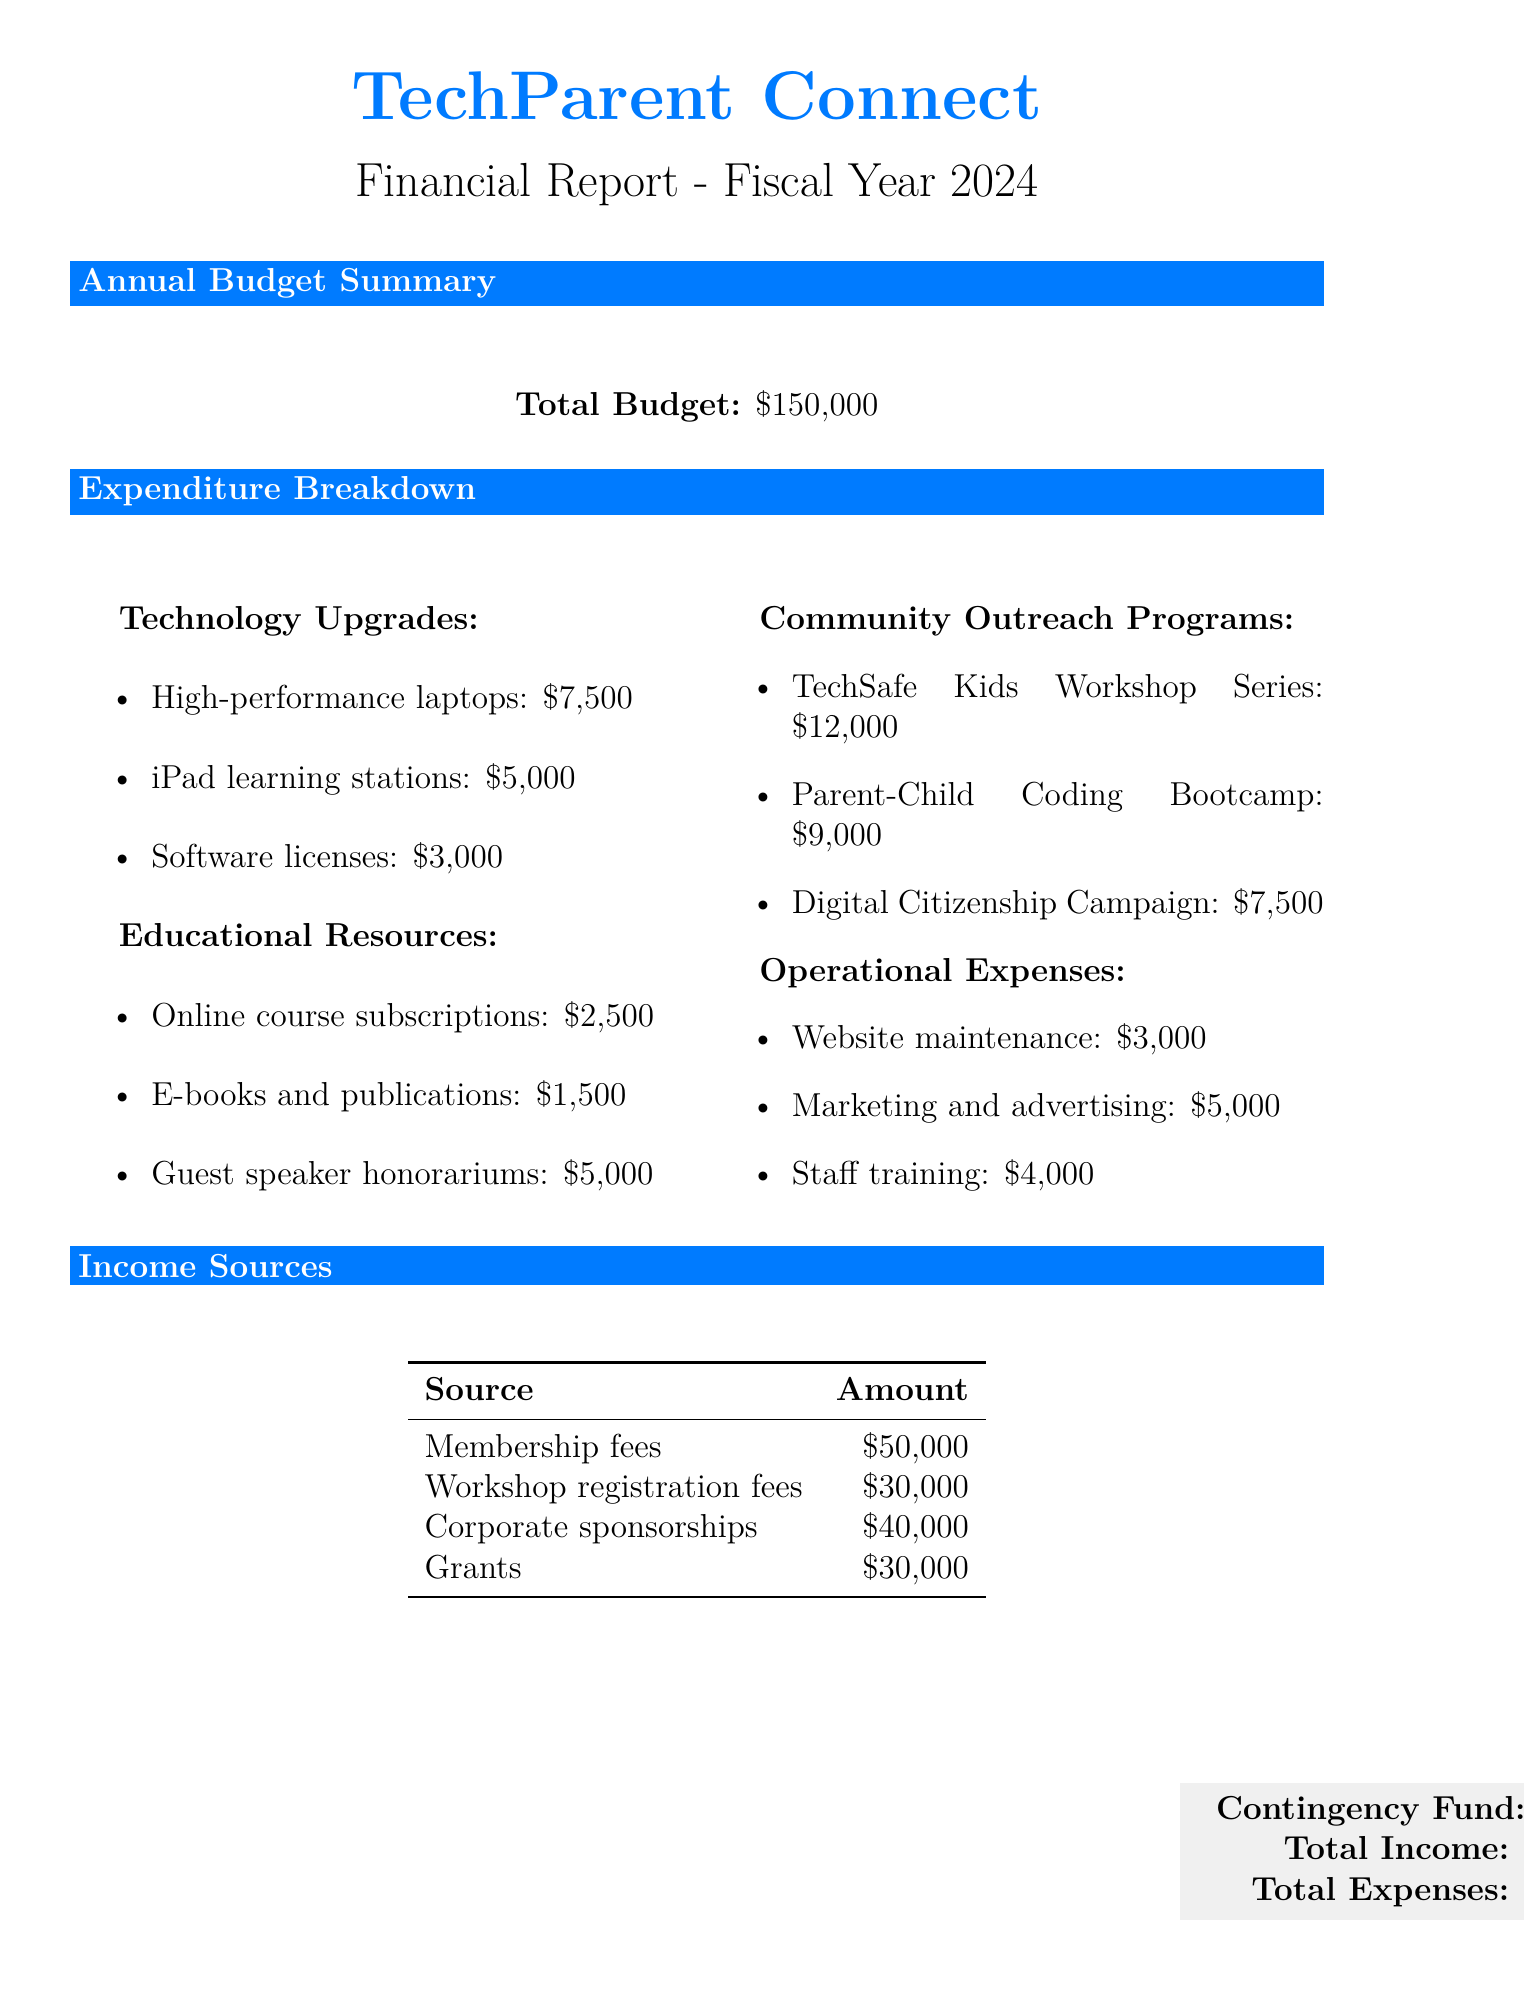What is the total budget? The total budget is provided in the annual budget summary section of the document, which states it is $150,000.
Answer: $150,000 How many high-performance laptops are allocated for staff? The technology upgrades section details the quantity of high-performance laptops, which is 5.
Answer: 5 What is the cost of guest speaker honorariums? The educational resources section specifies the cost of guest speaker honorariums, which is $5,000.
Answer: $5,000 How many sessions are planned for the Parent-Child Coding Bootcamp? The community outreach programs section lists the number of sessions specifically for the Parent-Child Coding Bootcamp, which is 6.
Answer: 6 What is the amount allocated for software licenses? The technology upgrades section mentions the cost allocated for software licenses, which is $3,000.
Answer: $3,000 What is the total amount of operational expenses? The operational expenses section lists the individual costs, which total $3,000 + $5,000 + $4,000 = $12,000.
Answer: $12,000 What is the amount of the contingency fund? The document includes a specific line for the contingency fund, which is stated as $10,000.
Answer: $10,000 What is the total income projected? The financial report summarizes projected income from various sources, totaling $150,000.
Answer: $150,000 